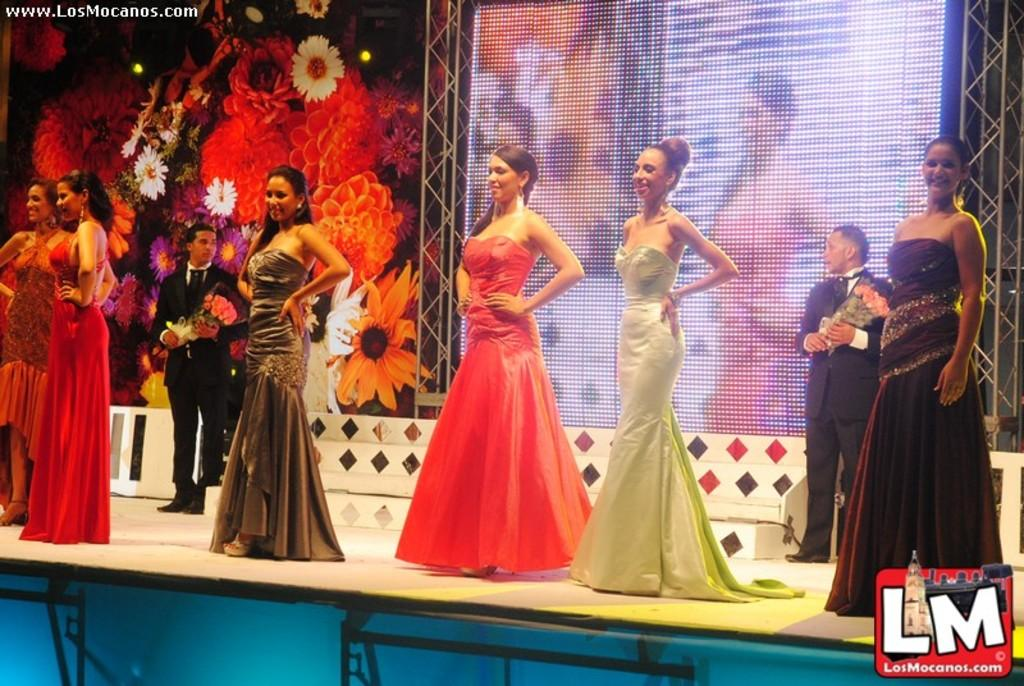What are the persons in the image doing? The persons in the image are standing on the stage. What can be seen in the background of the image? There are flowers and a screen in the background of the image. How many insurance policies are visible in the image? There are no insurance policies present in the image. What type of feet can be seen on the persons standing on the stage? The image does not show the feet of the persons standing on the stage. 